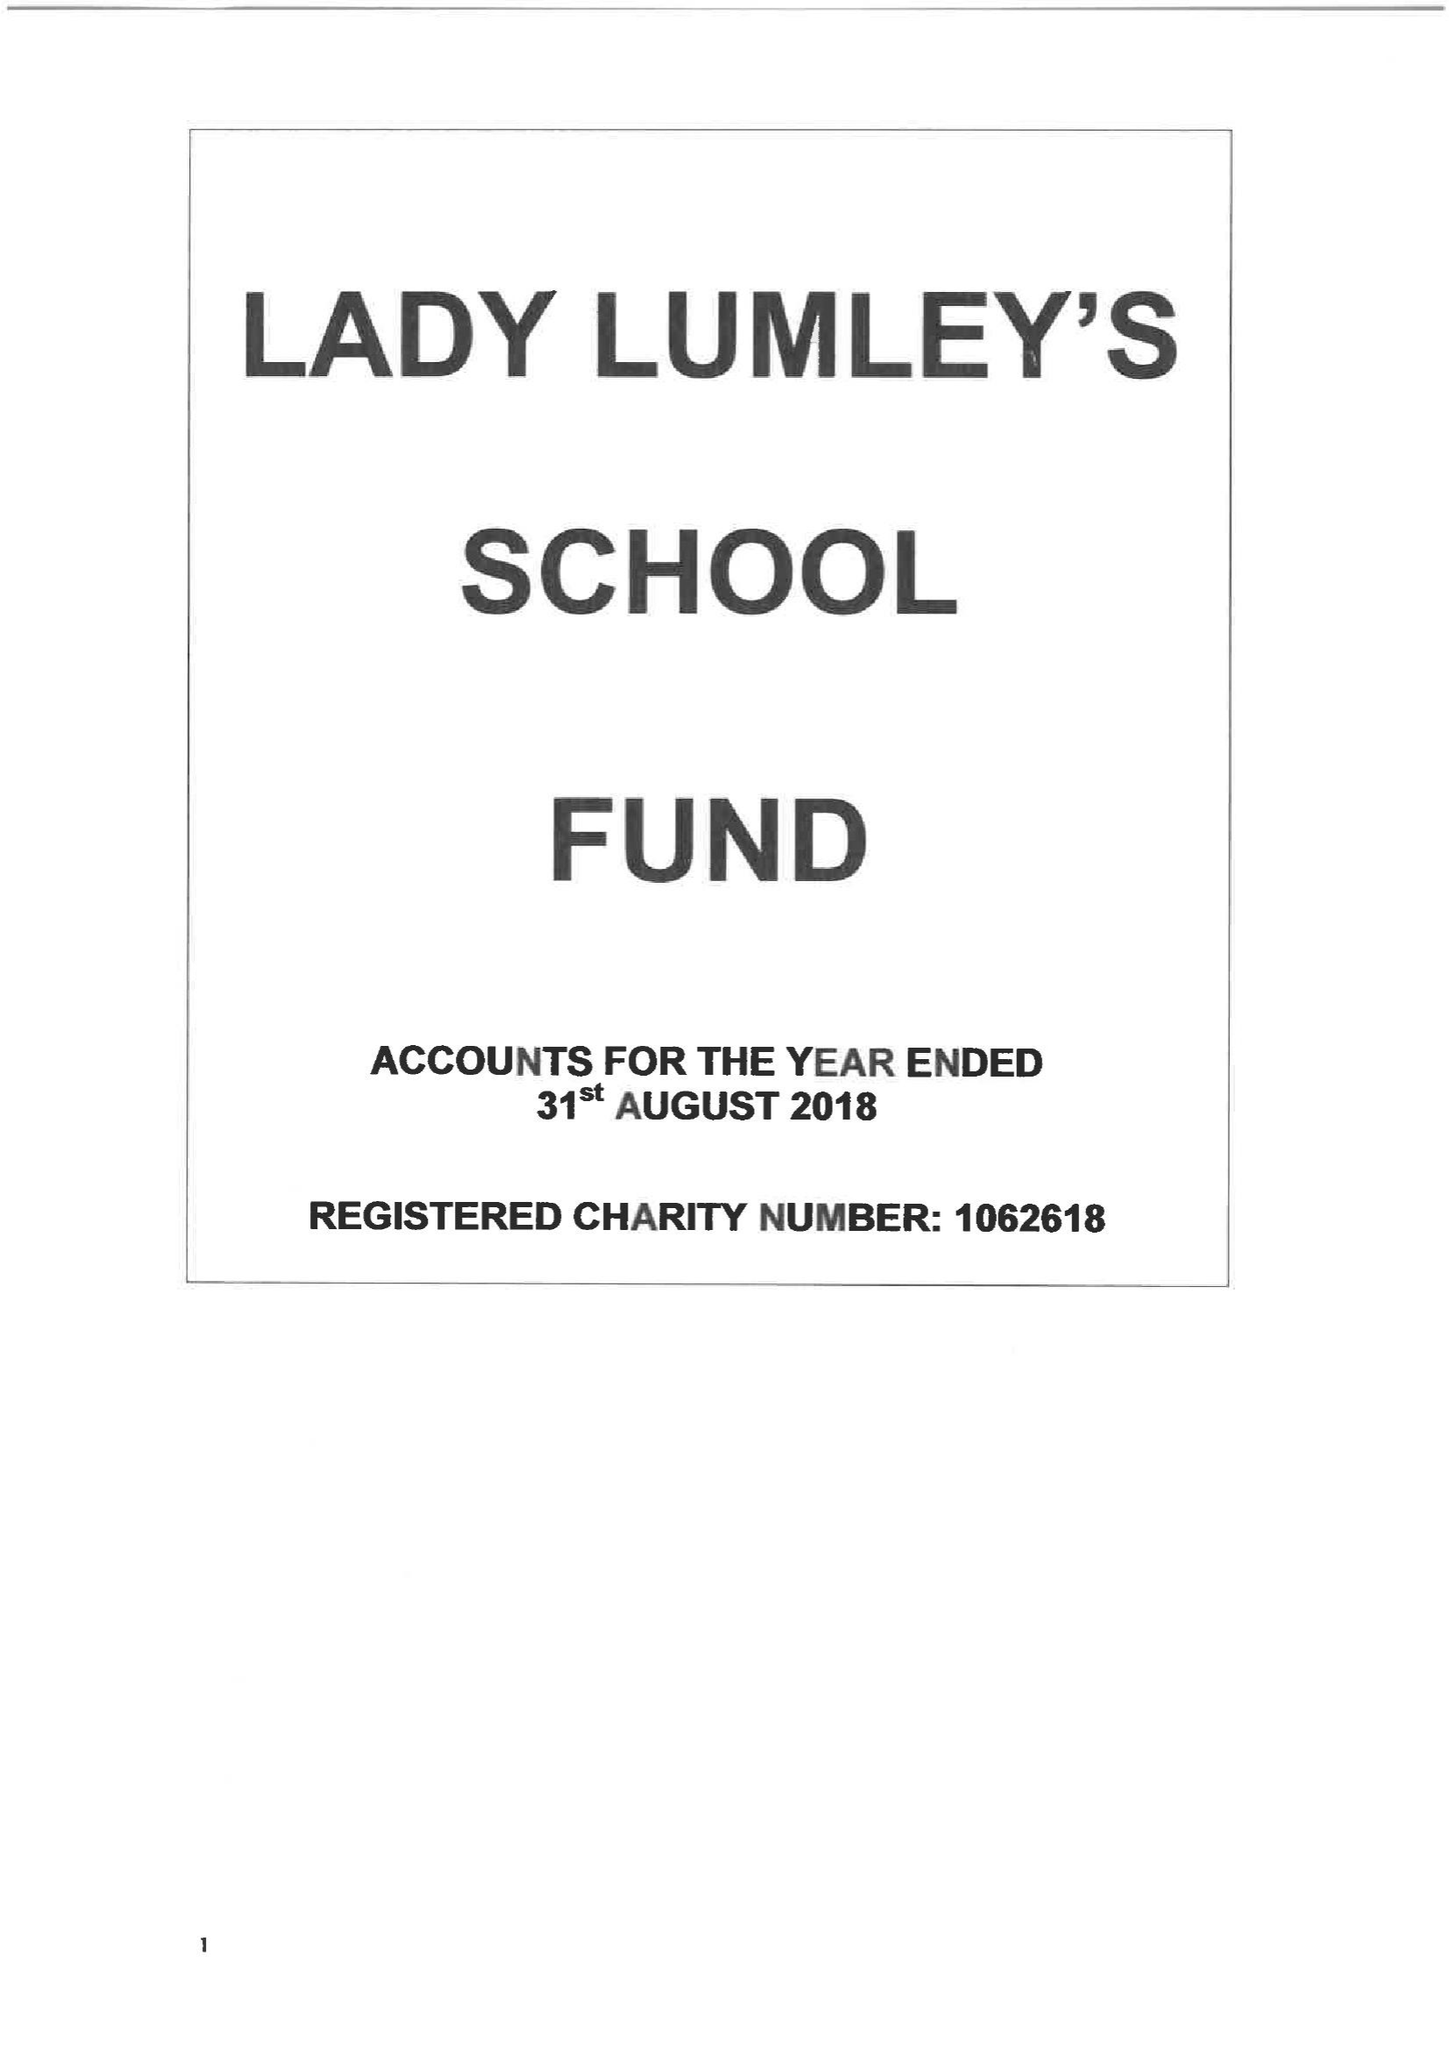What is the value for the charity_name?
Answer the question using a single word or phrase. Lady Lumley's School Fund 